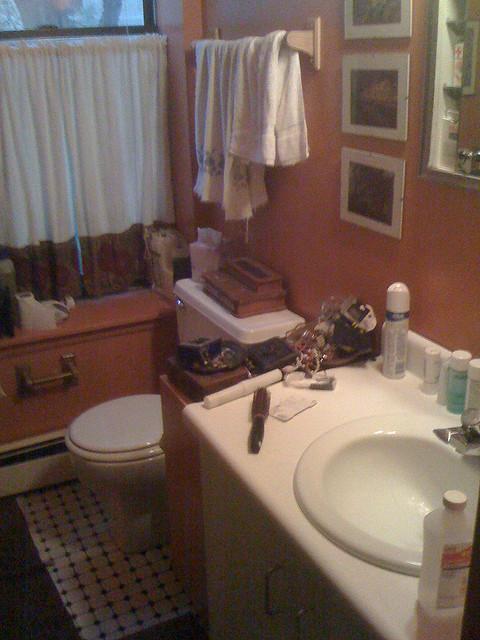How many bottles are in the picture?
Give a very brief answer. 2. How many people are sitting on the floor?
Give a very brief answer. 0. 